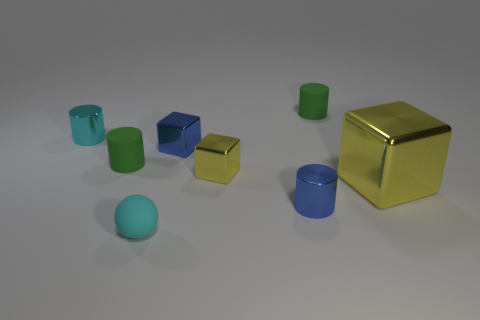Subtract all small metallic cubes. How many cubes are left? 1 Subtract all blue cylinders. How many cylinders are left? 3 Add 2 tiny green matte objects. How many objects exist? 10 Subtract all cubes. How many objects are left? 5 Subtract 3 cubes. How many cubes are left? 0 Subtract all red cubes. Subtract all blue cylinders. How many cubes are left? 3 Subtract all yellow blocks. How many blue cylinders are left? 1 Subtract all tiny green cylinders. Subtract all green cylinders. How many objects are left? 4 Add 7 blue cylinders. How many blue cylinders are left? 8 Add 6 shiny cubes. How many shiny cubes exist? 9 